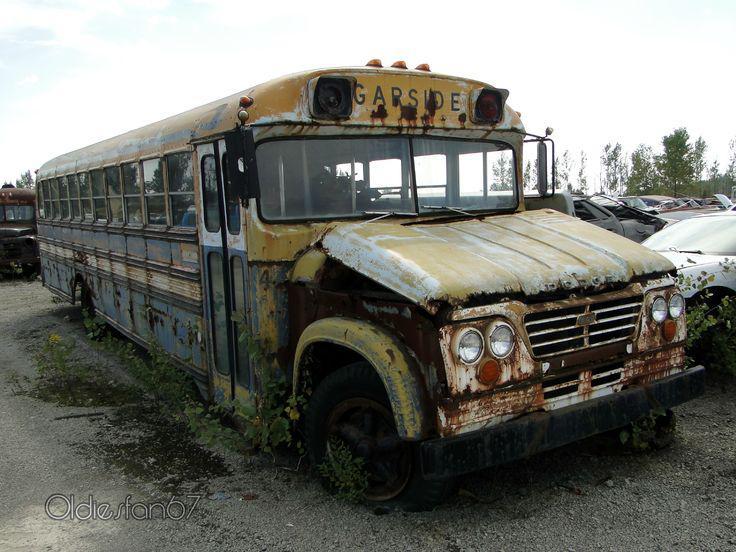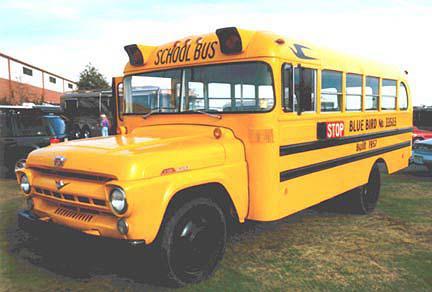The first image is the image on the left, the second image is the image on the right. Assess this claim about the two images: "The left image shows an angled, forward-facing bus with rust and other condition issues, and the right image features a leftward-angled bus in good condition.". Correct or not? Answer yes or no. Yes. The first image is the image on the left, the second image is the image on the right. Evaluate the accuracy of this statement regarding the images: "There are at least 12 window on the rusted out bus.". Is it true? Answer yes or no. Yes. 